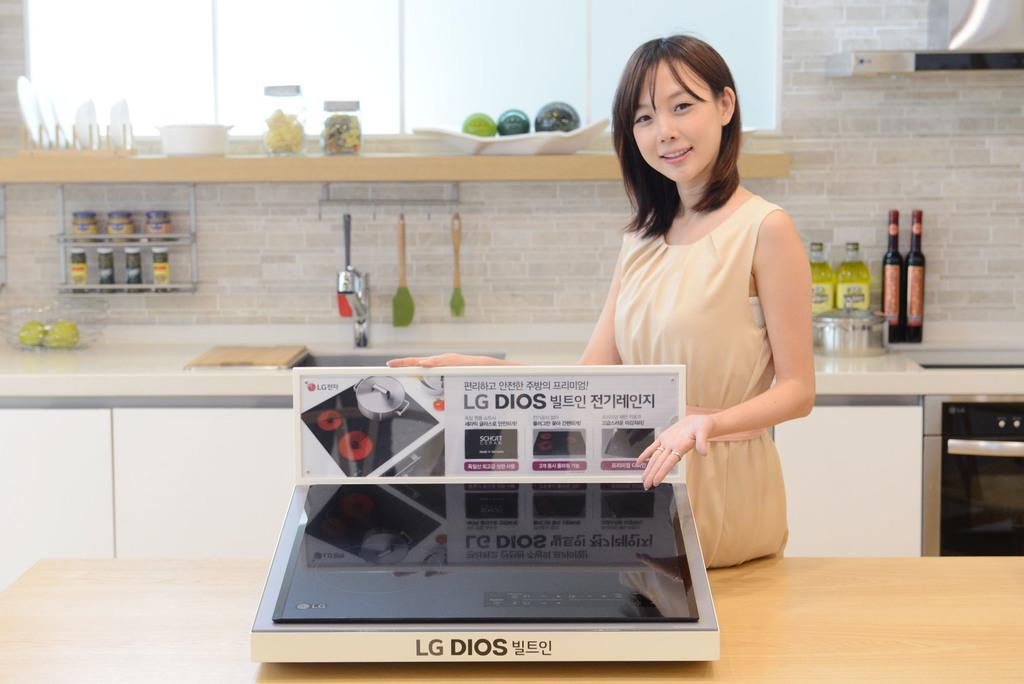<image>
Provide a brief description of the given image. a woman standing in a kitchen holding an LG DIOS machine 